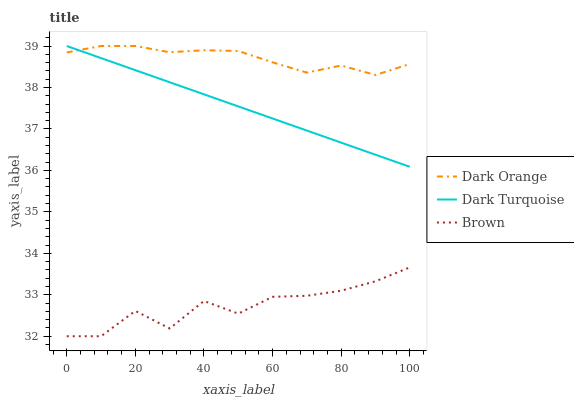Does Brown have the minimum area under the curve?
Answer yes or no. Yes. Does Dark Orange have the maximum area under the curve?
Answer yes or no. Yes. Does Dark Turquoise have the minimum area under the curve?
Answer yes or no. No. Does Dark Turquoise have the maximum area under the curve?
Answer yes or no. No. Is Dark Turquoise the smoothest?
Answer yes or no. Yes. Is Brown the roughest?
Answer yes or no. Yes. Is Brown the smoothest?
Answer yes or no. No. Is Dark Turquoise the roughest?
Answer yes or no. No. Does Brown have the lowest value?
Answer yes or no. Yes. Does Dark Turquoise have the lowest value?
Answer yes or no. No. Does Dark Turquoise have the highest value?
Answer yes or no. Yes. Does Brown have the highest value?
Answer yes or no. No. Is Brown less than Dark Turquoise?
Answer yes or no. Yes. Is Dark Turquoise greater than Brown?
Answer yes or no. Yes. Does Dark Orange intersect Dark Turquoise?
Answer yes or no. Yes. Is Dark Orange less than Dark Turquoise?
Answer yes or no. No. Is Dark Orange greater than Dark Turquoise?
Answer yes or no. No. Does Brown intersect Dark Turquoise?
Answer yes or no. No. 